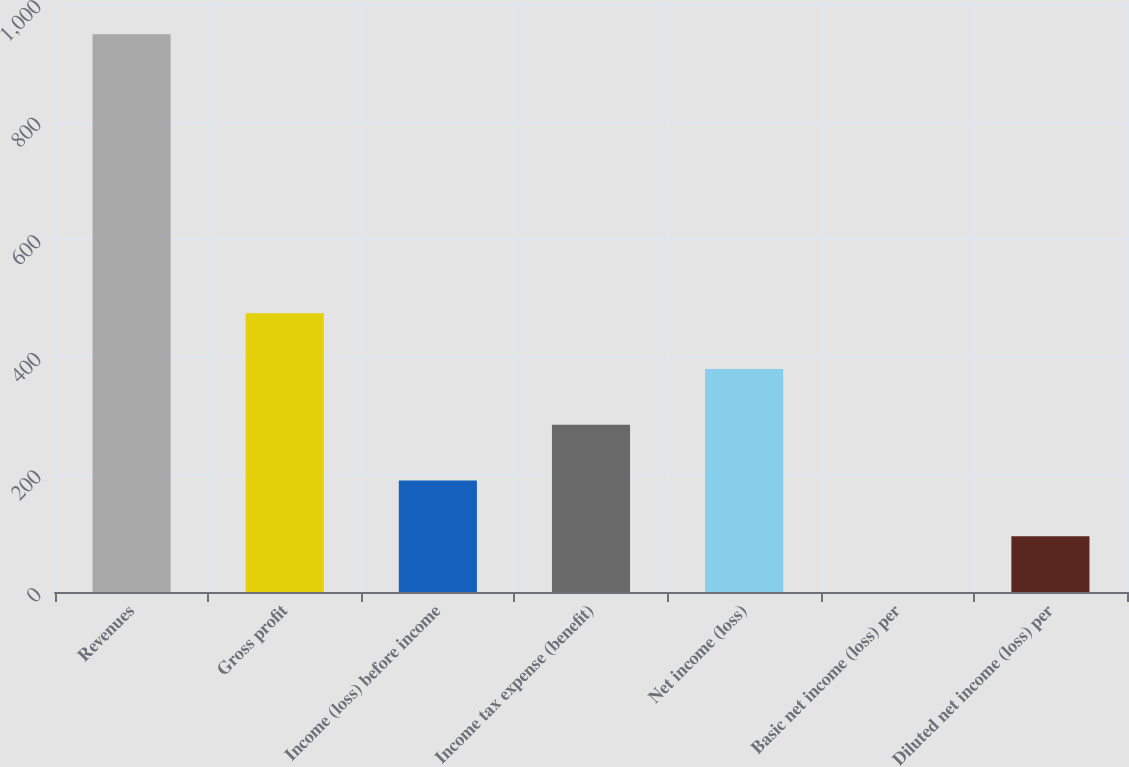Convert chart. <chart><loc_0><loc_0><loc_500><loc_500><bar_chart><fcel>Revenues<fcel>Gross profit<fcel>Income (loss) before income<fcel>Income tax expense (benefit)<fcel>Net income (loss)<fcel>Basic net income (loss) per<fcel>Diluted net income (loss) per<nl><fcel>948.4<fcel>474.23<fcel>189.71<fcel>284.55<fcel>379.39<fcel>0.03<fcel>94.87<nl></chart> 